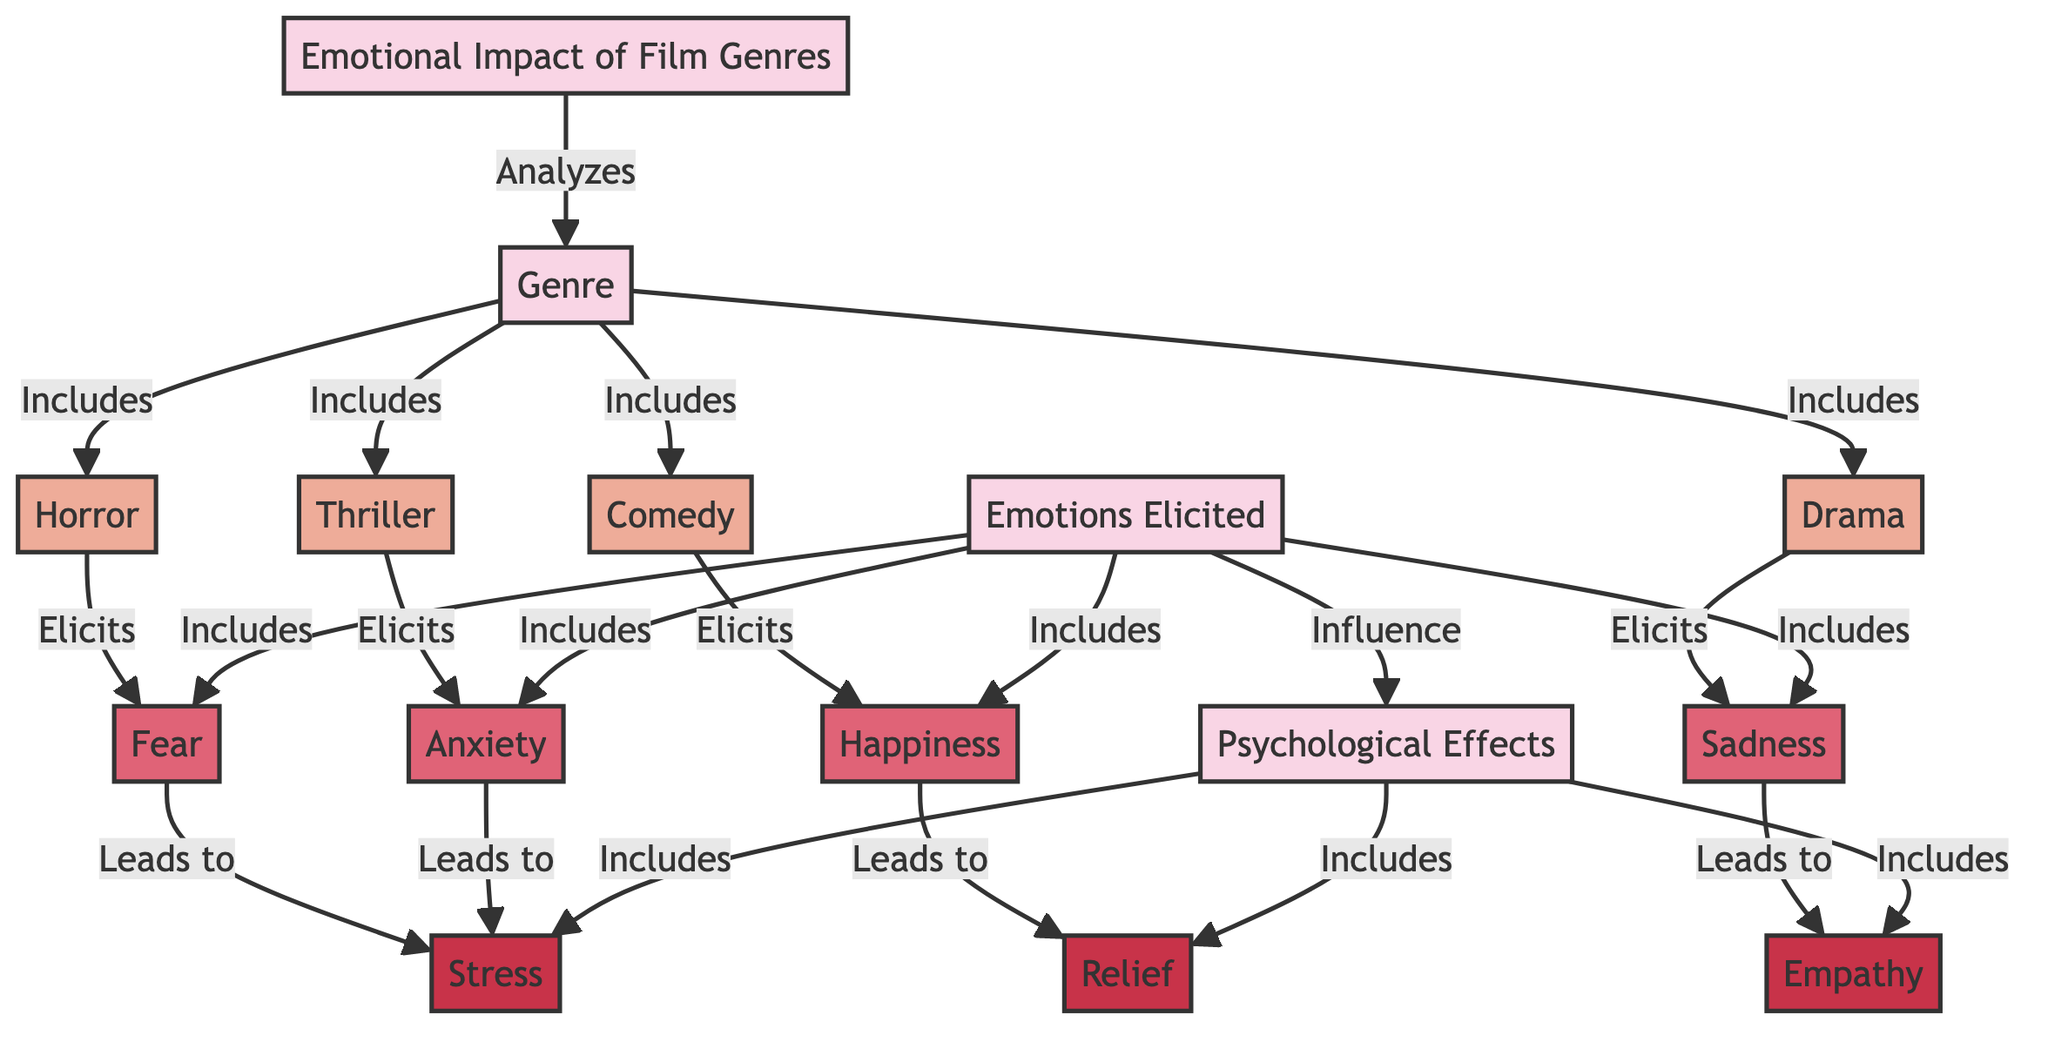What are the genres analyzed in the diagram? The diagram outlines four specific genres analyzed: Horror, Comedy, Drama, and Thriller. These can be found as nodes directly connected under the "Genre" node.
Answer: Horror, Comedy, Drama, Thriller Which emotion is elicited by drama? The diagram indicates that the emotion associated with Drama is Sadness, as indicated by the connection from the Drama node to the Sadness node.
Answer: Sadness How many emotions are included in this diagram? The diagram lists four specific emotions: Fear, Happiness, Sadness, and Anxiety, clearly identified under the "Emotions Elicited" node.
Answer: Four What psychological effect is associated with happiness? According to the diagram, Happiness leads to the psychological effect of Relief, which is denoted by the directed connection from the Happiness node to the Relief node.
Answer: Relief Which genre elicits anxiety? The diagram specifies that Anxiety is elicited by the Thriller genre, as represented by the direct connection from the Thriller node to the Anxiety node.
Answer: Thriller What is the relationship between fear and stress? The diagram shows that Fear leads to Stress, illustrating a cause-and-effect relationship via a directed connection from the Fear node to the Stress node.
Answer: Leads to What influences psychological effects according to the diagram? The diagram indicates that the "Emotions Elicited" node influences the "Psychological Effects" node, establishing a direct impact relationship.
Answer: Emotions Elicited Which psychological effects are included in the diagram? The diagram identifies three psychological effects: Stress, Relief, and Empathy, grouped under the "Psychological Effects" node.
Answer: Stress, Relief, Empathy 